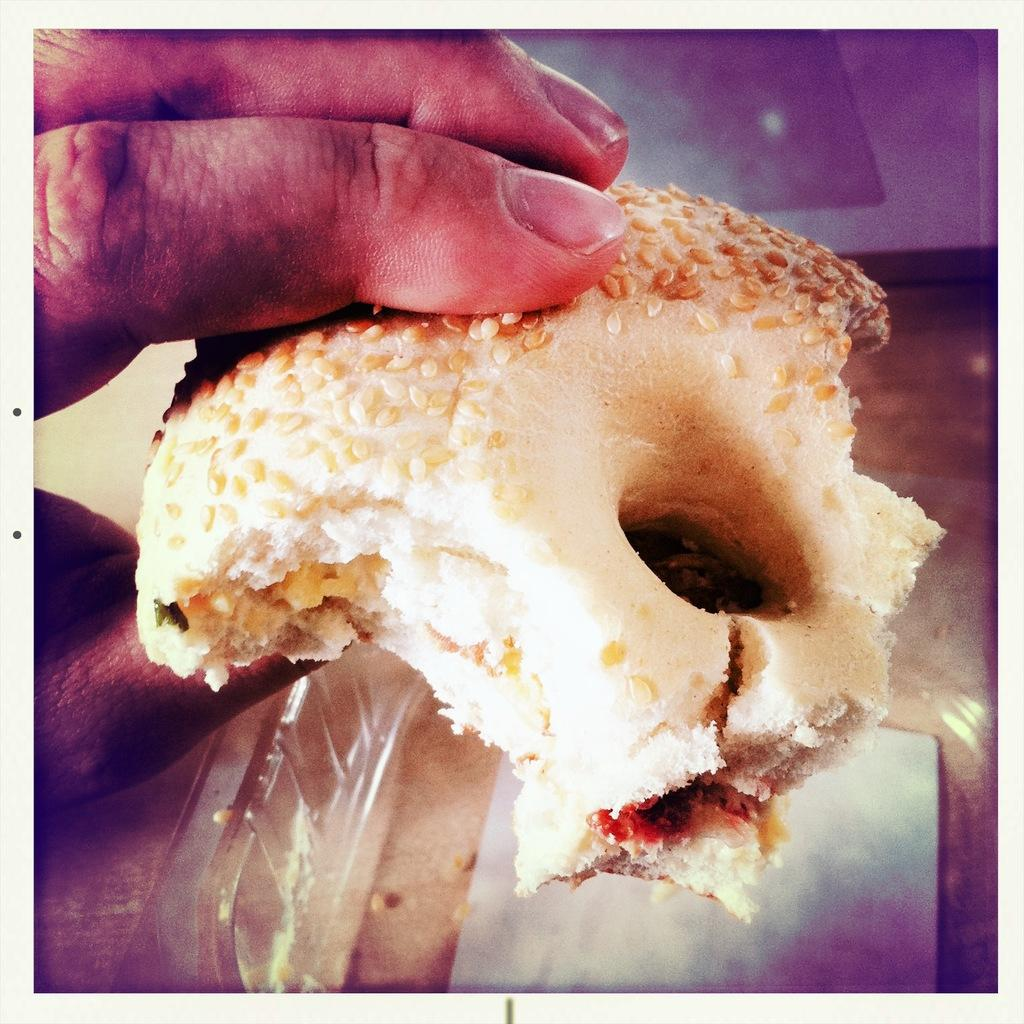What is the person in the image holding? The person is holding a doughnut. What is the condition of the doughnut? The doughnut is half bitten. Can you describe any other objects in the image? There is a plastic box in the background of the image. What type of destruction can be seen in the image? There is no destruction present in the image; it features a person holding a half-bitten doughnut and a plastic box in the background. How many beads are visible in the image? There are no beads present in the image. 